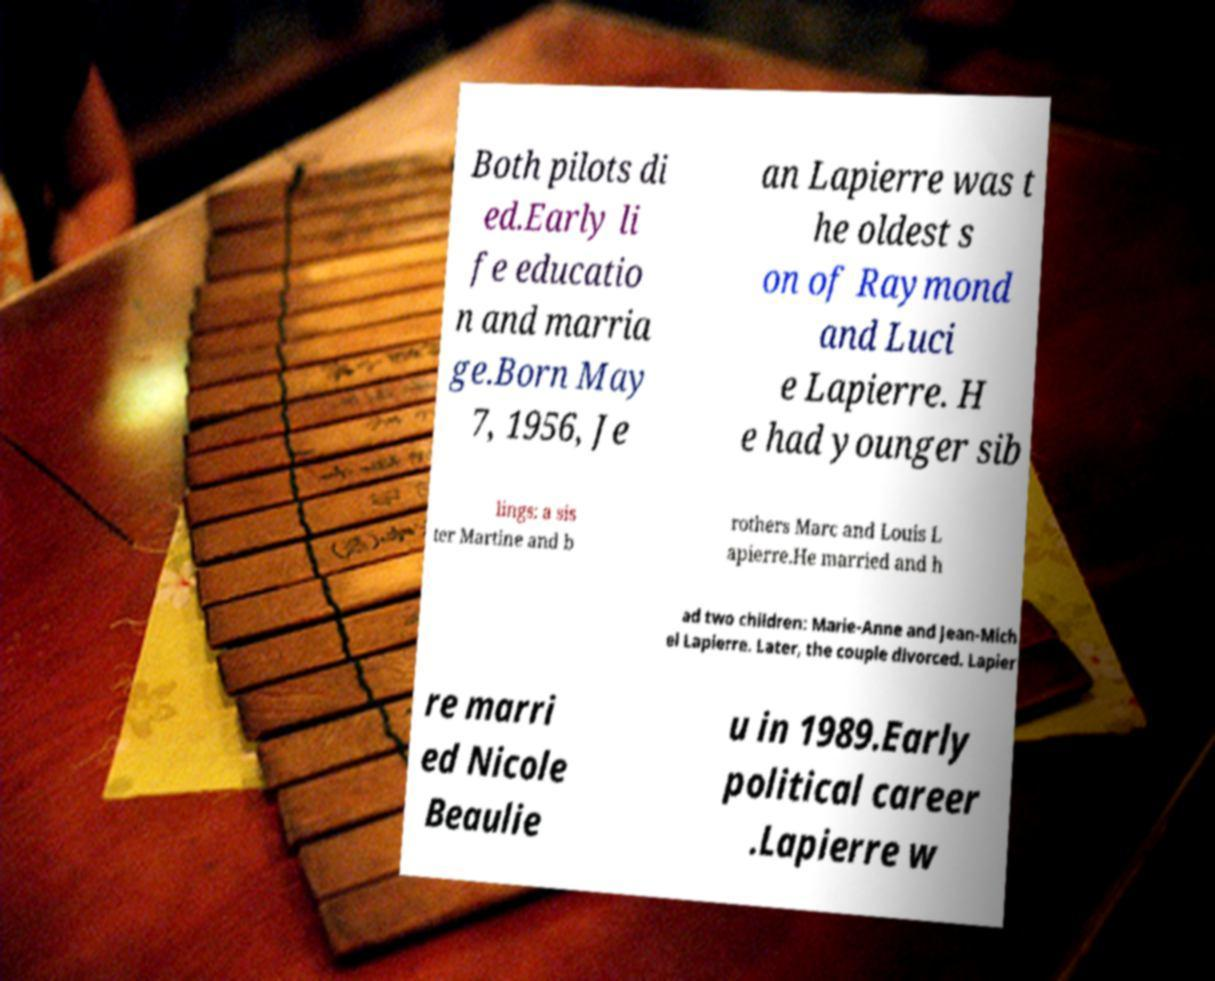Can you read and provide the text displayed in the image?This photo seems to have some interesting text. Can you extract and type it out for me? Both pilots di ed.Early li fe educatio n and marria ge.Born May 7, 1956, Je an Lapierre was t he oldest s on of Raymond and Luci e Lapierre. H e had younger sib lings: a sis ter Martine and b rothers Marc and Louis L apierre.He married and h ad two children: Marie-Anne and Jean-Mich el Lapierre. Later, the couple divorced. Lapier re marri ed Nicole Beaulie u in 1989.Early political career .Lapierre w 